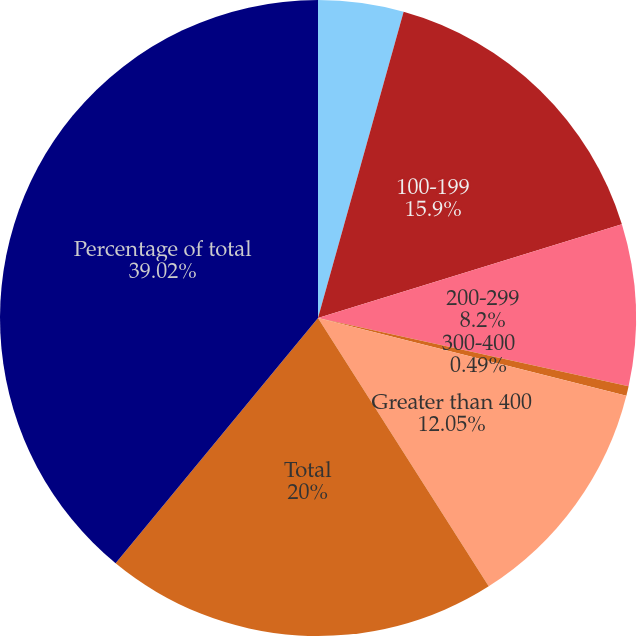Convert chart. <chart><loc_0><loc_0><loc_500><loc_500><pie_chart><fcel>Less than 100<fcel>100-199<fcel>200-299<fcel>300-400<fcel>Greater than 400<fcel>Total<fcel>Percentage of total<nl><fcel>4.34%<fcel>15.9%<fcel>8.2%<fcel>0.49%<fcel>12.05%<fcel>20.0%<fcel>39.02%<nl></chart> 